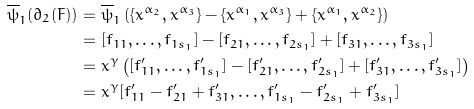Convert formula to latex. <formula><loc_0><loc_0><loc_500><loc_500>\overline { \psi } _ { 1 } ( \partial _ { 2 } ( F ) ) & = \overline { \psi } _ { 1 } \left ( \{ x ^ { \alpha _ { 2 } } , x ^ { \alpha _ { 3 } } \} - \{ x ^ { \alpha _ { 1 } } , x ^ { \alpha _ { 3 } } \} + \{ x ^ { \alpha _ { 1 } } , x ^ { \alpha _ { 2 } } \} \right ) \\ & = [ f _ { 1 1 } , \dots , f _ { 1 s _ { 1 } } ] - [ f _ { 2 1 } , \dots , f _ { 2 s _ { 1 } } ] + [ f _ { 3 1 } , \dots , f _ { 3 s _ { 1 } } ] \\ & = x ^ { \gamma } \left ( [ f ^ { \prime } _ { 1 1 } , \dots , f ^ { \prime } _ { 1 s _ { 1 } } ] - [ f ^ { \prime } _ { 2 1 } , \dots , f ^ { \prime } _ { 2 s _ { 1 } } ] + [ f ^ { \prime } _ { 3 1 } , \dots , f ^ { \prime } _ { 3 s _ { 1 } } ] \right ) \\ & = x ^ { \gamma } [ f ^ { \prime } _ { 1 1 } - f ^ { \prime } _ { 2 1 } + f ^ { \prime } _ { 3 1 } , \dots , f ^ { \prime } _ { 1 s _ { 1 } } - f ^ { \prime } _ { 2 s _ { 1 } } + f ^ { \prime } _ { 3 s _ { 1 } } ]</formula> 